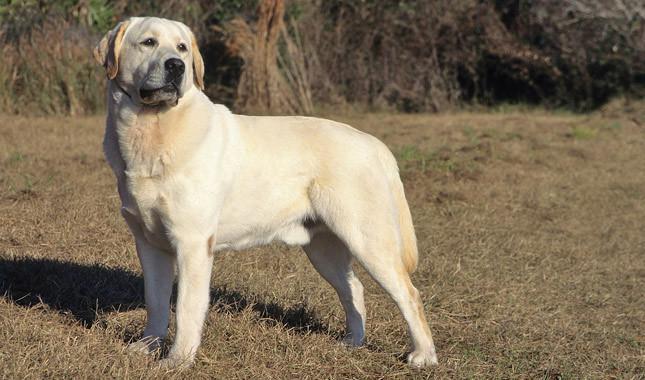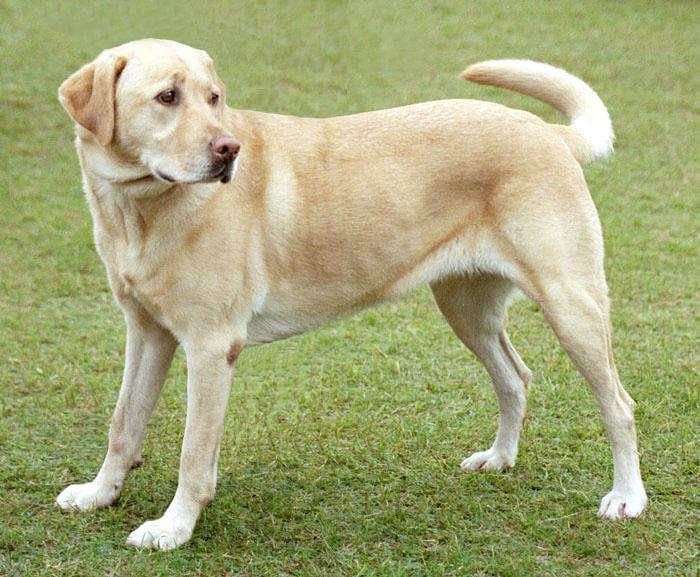The first image is the image on the left, the second image is the image on the right. Analyze the images presented: Is the assertion "In 1 of the images, a dog is standing on grass." valid? Answer yes or no. Yes. 